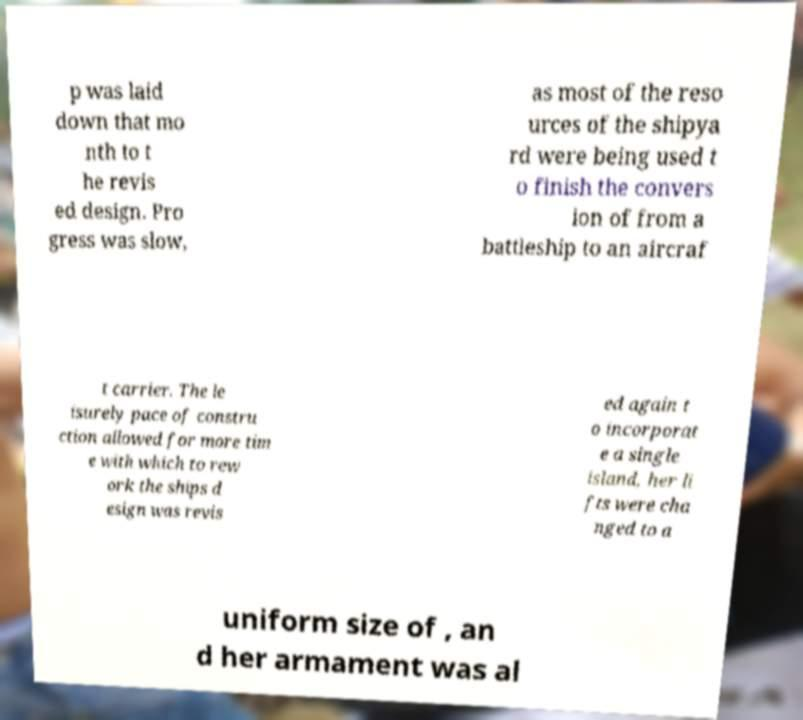There's text embedded in this image that I need extracted. Can you transcribe it verbatim? p was laid down that mo nth to t he revis ed design. Pro gress was slow, as most of the reso urces of the shipya rd were being used t o finish the convers ion of from a battleship to an aircraf t carrier. The le isurely pace of constru ction allowed for more tim e with which to rew ork the ships d esign was revis ed again t o incorporat e a single island, her li fts were cha nged to a uniform size of , an d her armament was al 